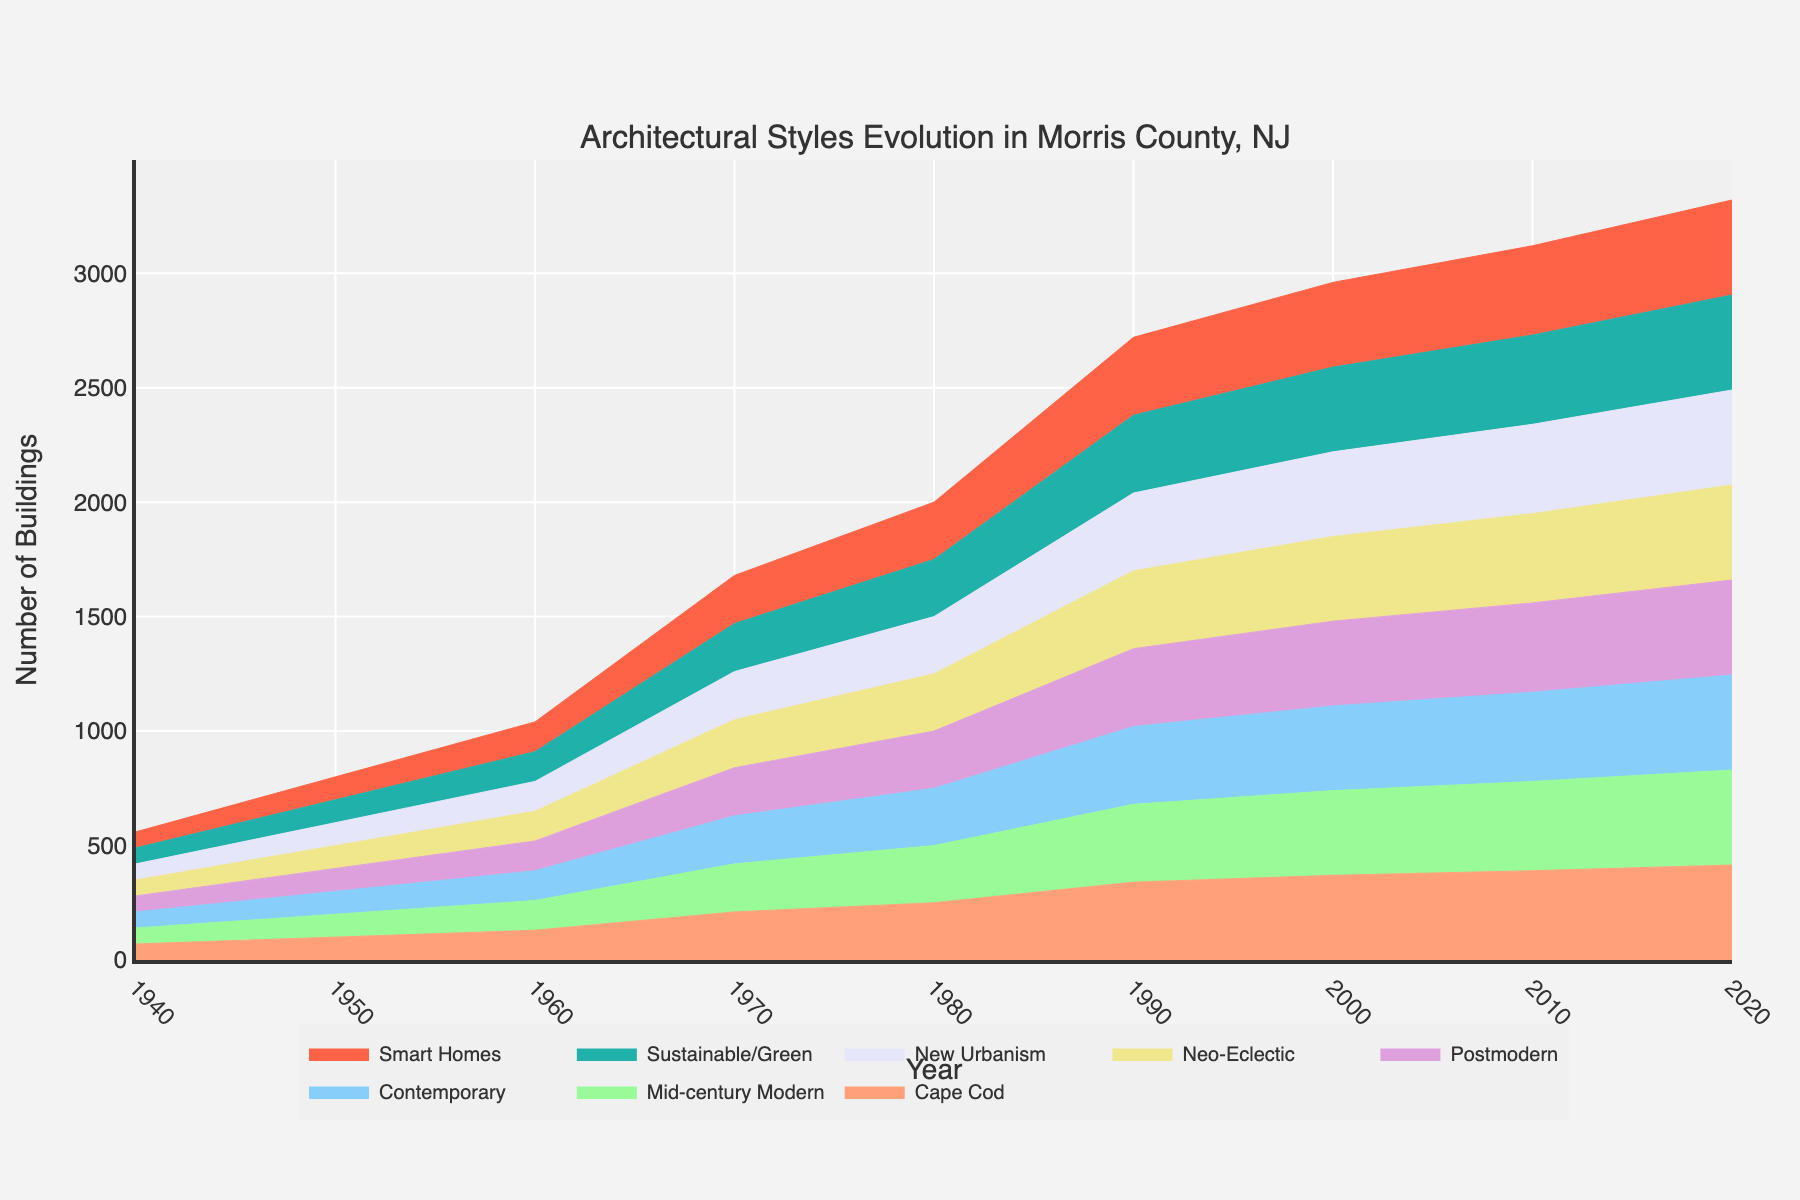What's the title of the figure? The title is usually placed at the top of the figure. In this case, it reads "Architectural Styles Evolution in Morris County, NJ."
Answer: Architectural Styles Evolution in Morris County, NJ What is the y-axis labeled in the figure? The y-axis label is typically placed alongside the vertical axis. Here it is labeled "Number of Buildings."
Answer: Number of Buildings Which architectural style had the highest number of buildings in the 1990s? By examining the step area chart, we see the height of the respective section for the 1990s. The Neo-Eclectic style has the highest cumulative count at this period.
Answer: Neo-Eclectic What are the key architectural attributes of Smart Homes as denoted in the figure? Hovering over the Smart Homes segment or referring to the text information, the attributes are "Integration of technology; energy-saving features; modular design."
Answer: Integration of technology; energy-saving features; modular design How does the number of buildings constructed in the 1980s compare to those constructed in the 1940s? We need to check the cumulative number of buildings at the end of the 1940s and the 1980s. The difference between those values gives us the number of 1980s buildings. Subtracting 1940s (70 buildings) from 1980s cumulative (250 buildings), we get 180 new buildings in the 1980s.
Answer: 180 more buildings Which two decades show a decline in the number of buildings constructed, and what is the cumulative difference? We need to look for the segments where the cumulative area decreases. The figure shows declines in the 2000s and 2010s. Number of buildings drops from 90 in the 1990s to 30 in the 2000s (60 fewer) and further down to 20 in the 2010s (10 fewer). The total difference is 60 + 10 = 70 buildings.
Answer: 2000s and 2010s; 70 buildings What is the cumulative number of buildings for Mid-century Modern and Postmodern styles combined? First, identify the cumulative number for each by examining their respective sections, then sum them. 60 (Mid-century Modern) + 40 (Postmodern) = 100 buildings.
Answer: 100 buildings Which architectural style reached its peak in the 2020s, and what features characterize this style? By finding the last segment and hovering over it, we see that Smart Homes reached their peak in the 2020s. The key attributes include "Integration of technology; energy-saving features; modular design."
Answer: Smart Homes; Integration of technology; energy-saving features; modular design Between which two decades did Sustainable/Green architecture first appear, and what was the change in the number of buildings? Review the pattern changes between decades. Sustainable/Green architecture appears between the 2000s and the 2010s, when it grew from 0 to 20 buildings.
Answer: 2000s and 2010s; 20 buildings How many buildings were constructed in Morris County during the 1970s, and what were the predominant architectural attributes? We can observe from the 1970s segment's height. Contemporary style is predominant, with a count of 80 new buildings. The attributes include "Experimental forms; traditional and non-traditional materials; open floor plans."
Answer: 80 buildings; Experimental forms; traditional and non-traditional materials; open floor plans 